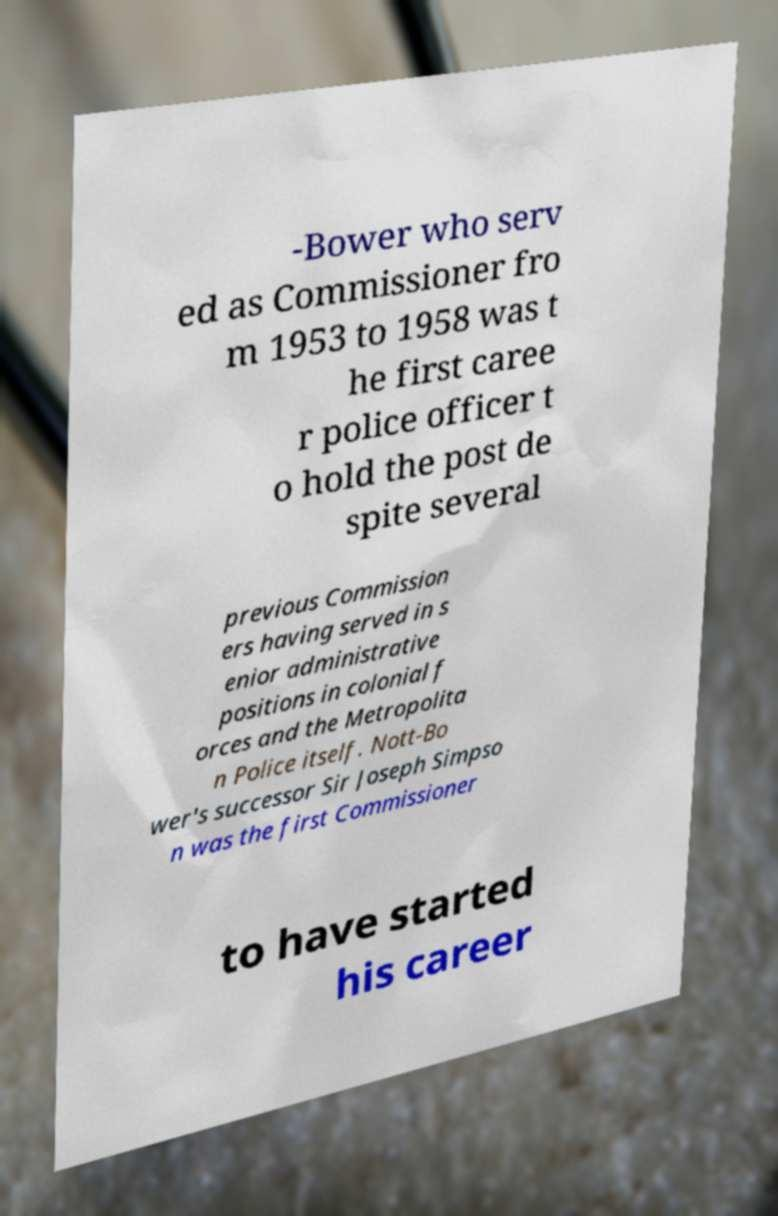Can you read and provide the text displayed in the image?This photo seems to have some interesting text. Can you extract and type it out for me? -Bower who serv ed as Commissioner fro m 1953 to 1958 was t he first caree r police officer t o hold the post de spite several previous Commission ers having served in s enior administrative positions in colonial f orces and the Metropolita n Police itself. Nott-Bo wer's successor Sir Joseph Simpso n was the first Commissioner to have started his career 